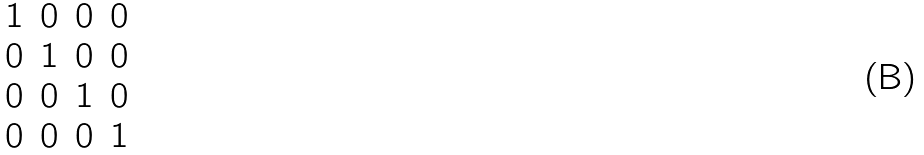<formula> <loc_0><loc_0><loc_500><loc_500>\begin{matrix} 1 & 0 & 0 & 0 \\ 0 & 1 & 0 & 0 \\ 0 & 0 & 1 & 0 \\ 0 & 0 & 0 & 1 \end{matrix}</formula> 